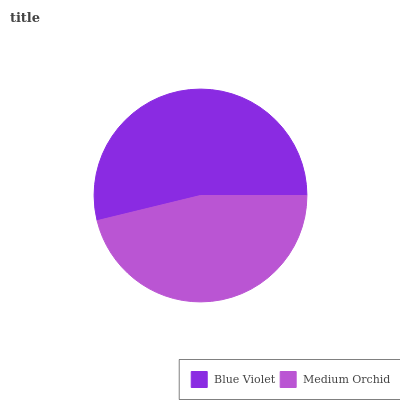Is Medium Orchid the minimum?
Answer yes or no. Yes. Is Blue Violet the maximum?
Answer yes or no. Yes. Is Medium Orchid the maximum?
Answer yes or no. No. Is Blue Violet greater than Medium Orchid?
Answer yes or no. Yes. Is Medium Orchid less than Blue Violet?
Answer yes or no. Yes. Is Medium Orchid greater than Blue Violet?
Answer yes or no. No. Is Blue Violet less than Medium Orchid?
Answer yes or no. No. Is Blue Violet the high median?
Answer yes or no. Yes. Is Medium Orchid the low median?
Answer yes or no. Yes. Is Medium Orchid the high median?
Answer yes or no. No. Is Blue Violet the low median?
Answer yes or no. No. 